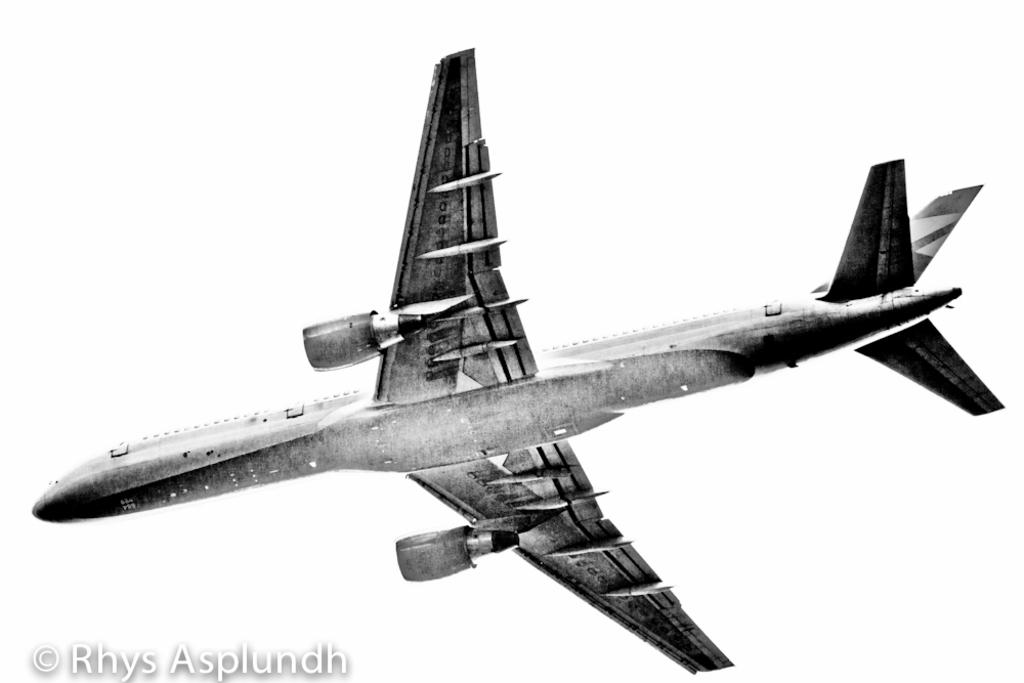What is the main subject of the image? The main subject of the image is an airplane. What is the airplane doing in the image? The airplane is flying in the sky. Is there any text present in the image? Yes, there is some text written in the bottom left of the image. What type of board can be seen in the image? There is no board present in the image; it features an airplane flying in the sky. What observation can be made about the plane in the image? The provided facts do not mention any specific observation about the plane, so it cannot be determined from the image. 